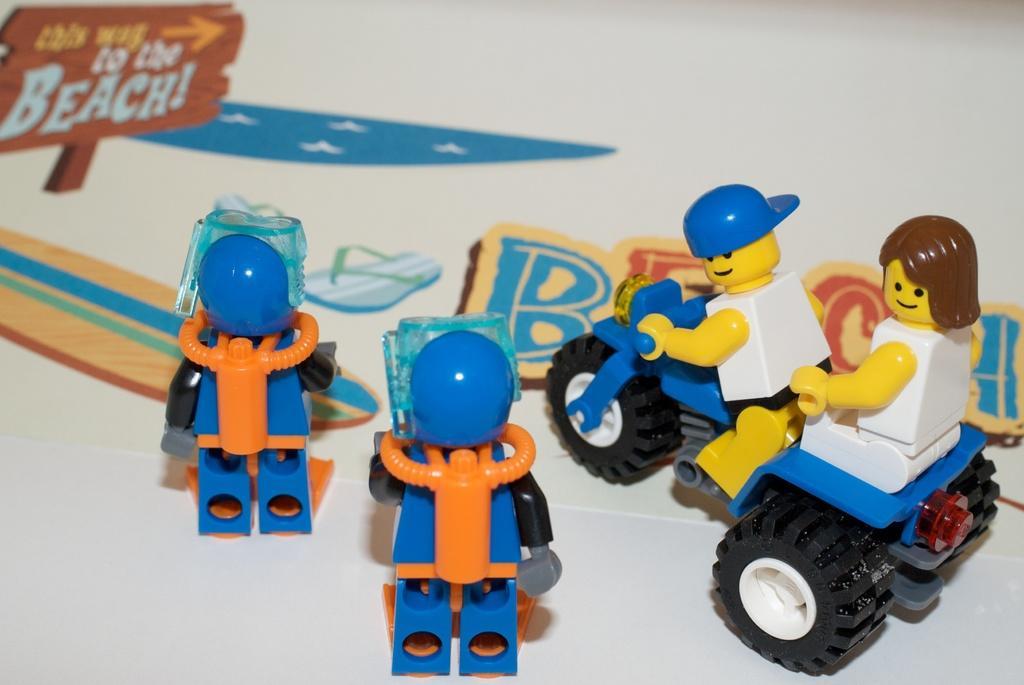In one or two sentences, can you explain what this image depicts? There are toys in the center of the image on a poster. 